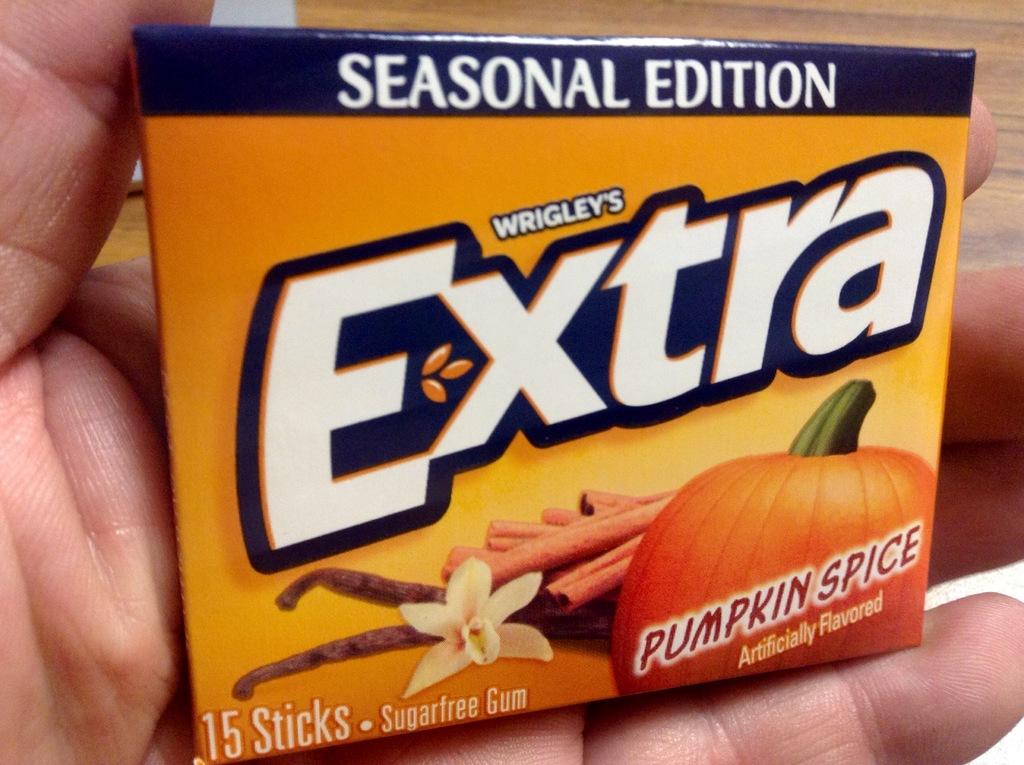What is the brand name of the gum?
Provide a short and direct response. Extra. What flavor is the gum?
Provide a succinct answer. Pumpkin spice. 